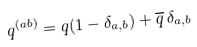<formula> <loc_0><loc_0><loc_500><loc_500>q ^ { ( a b ) } = q ( 1 - \delta _ { a , b } ) + { \overline { q } } \, \delta _ { a , b }</formula> 